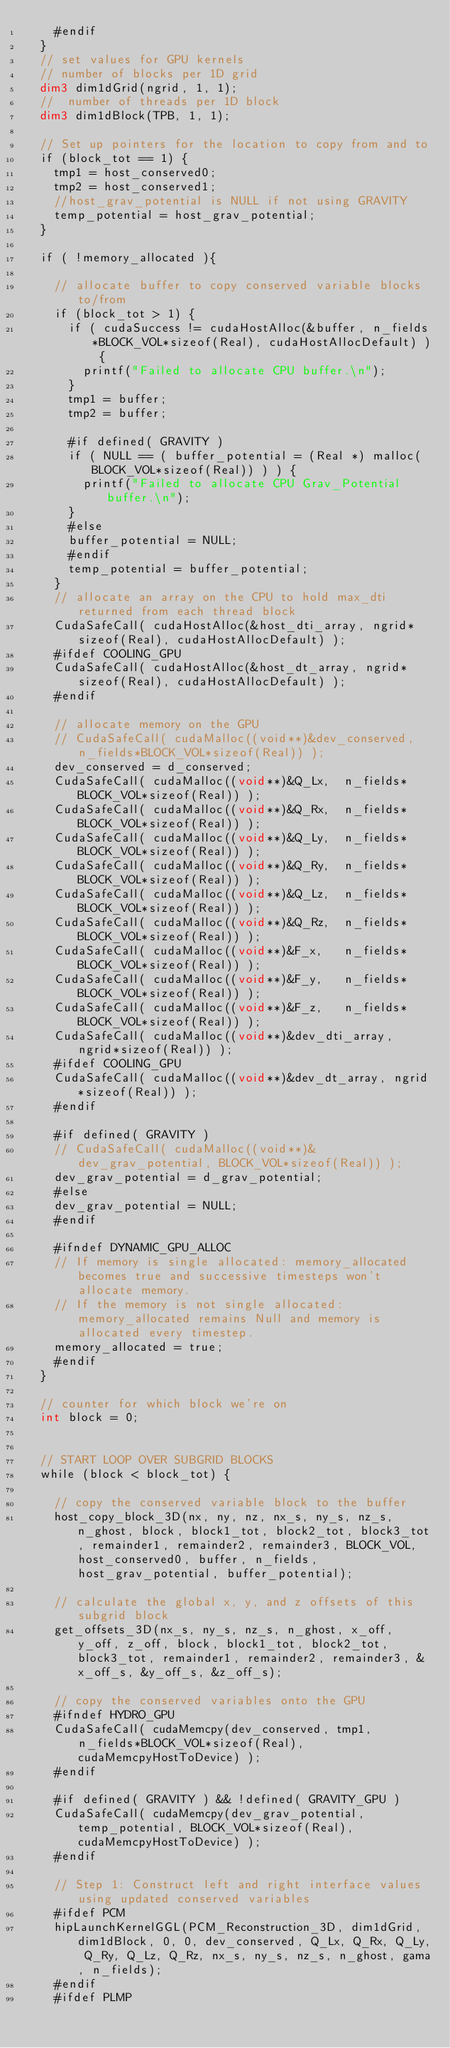<code> <loc_0><loc_0><loc_500><loc_500><_Cuda_>    #endif
  }
  // set values for GPU kernels
  // number of blocks per 1D grid
  dim3 dim1dGrid(ngrid, 1, 1);
  //  number of threads per 1D block
  dim3 dim1dBlock(TPB, 1, 1);

  // Set up pointers for the location to copy from and to
  if (block_tot == 1) {
    tmp1 = host_conserved0;
    tmp2 = host_conserved1;
    //host_grav_potential is NULL if not using GRAVITY
    temp_potential = host_grav_potential;
  }

  if ( !memory_allocated ){

    // allocate buffer to copy conserved variable blocks to/from
    if (block_tot > 1) {
      if ( cudaSuccess != cudaHostAlloc(&buffer, n_fields*BLOCK_VOL*sizeof(Real), cudaHostAllocDefault) ) {
        printf("Failed to allocate CPU buffer.\n");
      }
      tmp1 = buffer;
      tmp2 = buffer;

      #if defined( GRAVITY )
      if ( NULL == ( buffer_potential = (Real *) malloc(BLOCK_VOL*sizeof(Real)) ) ) {
        printf("Failed to allocate CPU Grav_Potential buffer.\n");
      }
      #else
      buffer_potential = NULL;
      #endif
      temp_potential = buffer_potential;
    }
    // allocate an array on the CPU to hold max_dti returned from each thread block
    CudaSafeCall( cudaHostAlloc(&host_dti_array, ngrid*sizeof(Real), cudaHostAllocDefault) );
    #ifdef COOLING_GPU
    CudaSafeCall( cudaHostAlloc(&host_dt_array, ngrid*sizeof(Real), cudaHostAllocDefault) );
    #endif

    // allocate memory on the GPU
    // CudaSafeCall( cudaMalloc((void**)&dev_conserved, n_fields*BLOCK_VOL*sizeof(Real)) );
    dev_conserved = d_conserved;
    CudaSafeCall( cudaMalloc((void**)&Q_Lx,  n_fields*BLOCK_VOL*sizeof(Real)) );
    CudaSafeCall( cudaMalloc((void**)&Q_Rx,  n_fields*BLOCK_VOL*sizeof(Real)) );
    CudaSafeCall( cudaMalloc((void**)&Q_Ly,  n_fields*BLOCK_VOL*sizeof(Real)) );
    CudaSafeCall( cudaMalloc((void**)&Q_Ry,  n_fields*BLOCK_VOL*sizeof(Real)) );
    CudaSafeCall( cudaMalloc((void**)&Q_Lz,  n_fields*BLOCK_VOL*sizeof(Real)) );
    CudaSafeCall( cudaMalloc((void**)&Q_Rz,  n_fields*BLOCK_VOL*sizeof(Real)) );
    CudaSafeCall( cudaMalloc((void**)&F_x,   n_fields*BLOCK_VOL*sizeof(Real)) );
    CudaSafeCall( cudaMalloc((void**)&F_y,   n_fields*BLOCK_VOL*sizeof(Real)) );
    CudaSafeCall( cudaMalloc((void**)&F_z,   n_fields*BLOCK_VOL*sizeof(Real)) );
    CudaSafeCall( cudaMalloc((void**)&dev_dti_array, ngrid*sizeof(Real)) );
    #ifdef COOLING_GPU
    CudaSafeCall( cudaMalloc((void**)&dev_dt_array, ngrid*sizeof(Real)) );
    #endif

    #if defined( GRAVITY )
    // CudaSafeCall( cudaMalloc((void**)&dev_grav_potential, BLOCK_VOL*sizeof(Real)) );
    dev_grav_potential = d_grav_potential;
    #else
    dev_grav_potential = NULL;
    #endif

    #ifndef DYNAMIC_GPU_ALLOC
    // If memory is single allocated: memory_allocated becomes true and successive timesteps won't allocate memory.
    // If the memory is not single allocated: memory_allocated remains Null and memory is allocated every timestep.
    memory_allocated = true;
    #endif
  }

  // counter for which block we're on
  int block = 0;


  // START LOOP OVER SUBGRID BLOCKS
  while (block < block_tot) {

    // copy the conserved variable block to the buffer
    host_copy_block_3D(nx, ny, nz, nx_s, ny_s, nz_s, n_ghost, block, block1_tot, block2_tot, block3_tot, remainder1, remainder2, remainder3, BLOCK_VOL, host_conserved0, buffer, n_fields, host_grav_potential, buffer_potential);

    // calculate the global x, y, and z offsets of this subgrid block
    get_offsets_3D(nx_s, ny_s, nz_s, n_ghost, x_off, y_off, z_off, block, block1_tot, block2_tot, block3_tot, remainder1, remainder2, remainder3, &x_off_s, &y_off_s, &z_off_s);

    // copy the conserved variables onto the GPU
    #ifndef HYDRO_GPU
    CudaSafeCall( cudaMemcpy(dev_conserved, tmp1, n_fields*BLOCK_VOL*sizeof(Real), cudaMemcpyHostToDevice) );
    #endif

    #if defined( GRAVITY ) && !defined( GRAVITY_GPU )
    CudaSafeCall( cudaMemcpy(dev_grav_potential, temp_potential, BLOCK_VOL*sizeof(Real), cudaMemcpyHostToDevice) );
    #endif

    // Step 1: Construct left and right interface values using updated conserved variables
    #ifdef PCM
    hipLaunchKernelGGL(PCM_Reconstruction_3D, dim1dGrid, dim1dBlock, 0, 0, dev_conserved, Q_Lx, Q_Rx, Q_Ly, Q_Ry, Q_Lz, Q_Rz, nx_s, ny_s, nz_s, n_ghost, gama, n_fields);
    #endif
    #ifdef PLMP</code> 